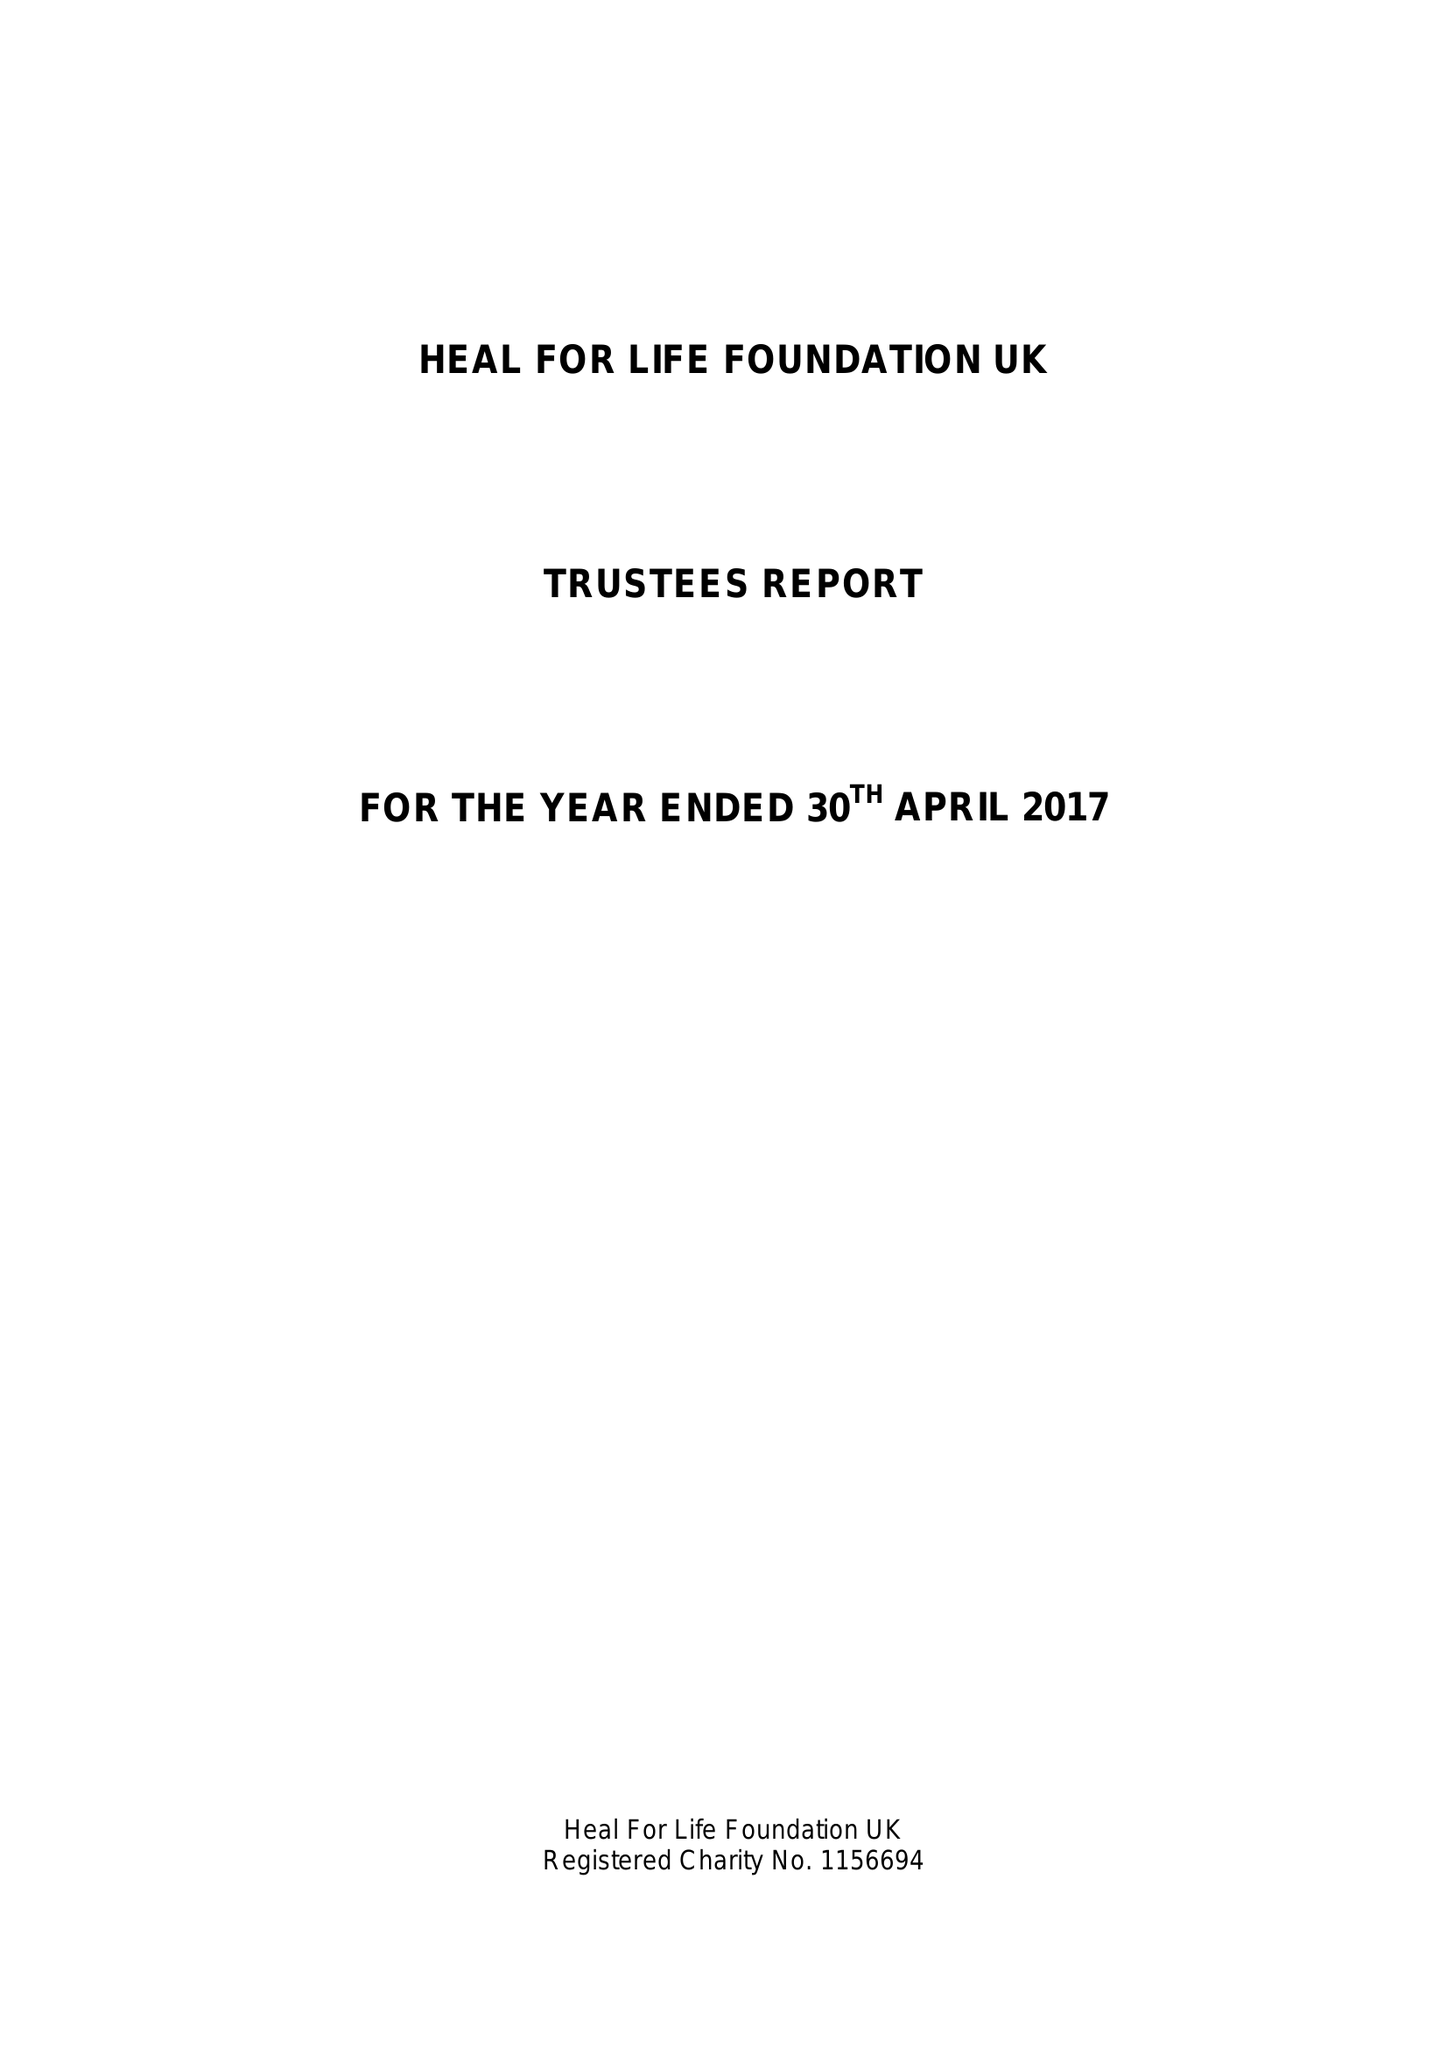What is the value for the address__post_town?
Answer the question using a single word or phrase. ASHFORD 